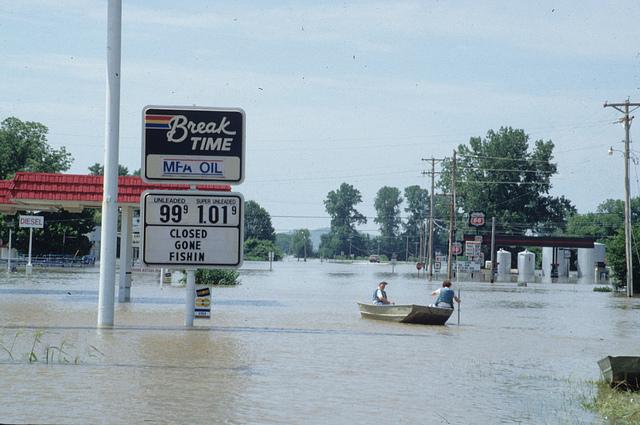What number is on the white sign?
Give a very brief answer. 99. Is there a flood?
Short answer required. Yes. What is there only one of when there should be a pair?
Write a very short answer. Oar. Which words have been added to the sign?
Give a very brief answer. Closed gone fishing. How much water is on the ground?
Short answer required. Lots. What does the sign say?
Quick response, please. Break time. What company billboard is in the background?
Concise answer only. Break time. Does this road have one or two directions of traffic?
Give a very brief answer. 2. Is this the type of vehicle usually moving in this area?
Concise answer only. No. What street sign is this?
Quick response, please. Gas station. Can people pick up their mail there?
Short answer required. No. What is covering the ground?
Give a very brief answer. Water. What does the largest sign say?
Be succinct. Break time. What type of work is going on ahead?
Short answer required. Rowing. 